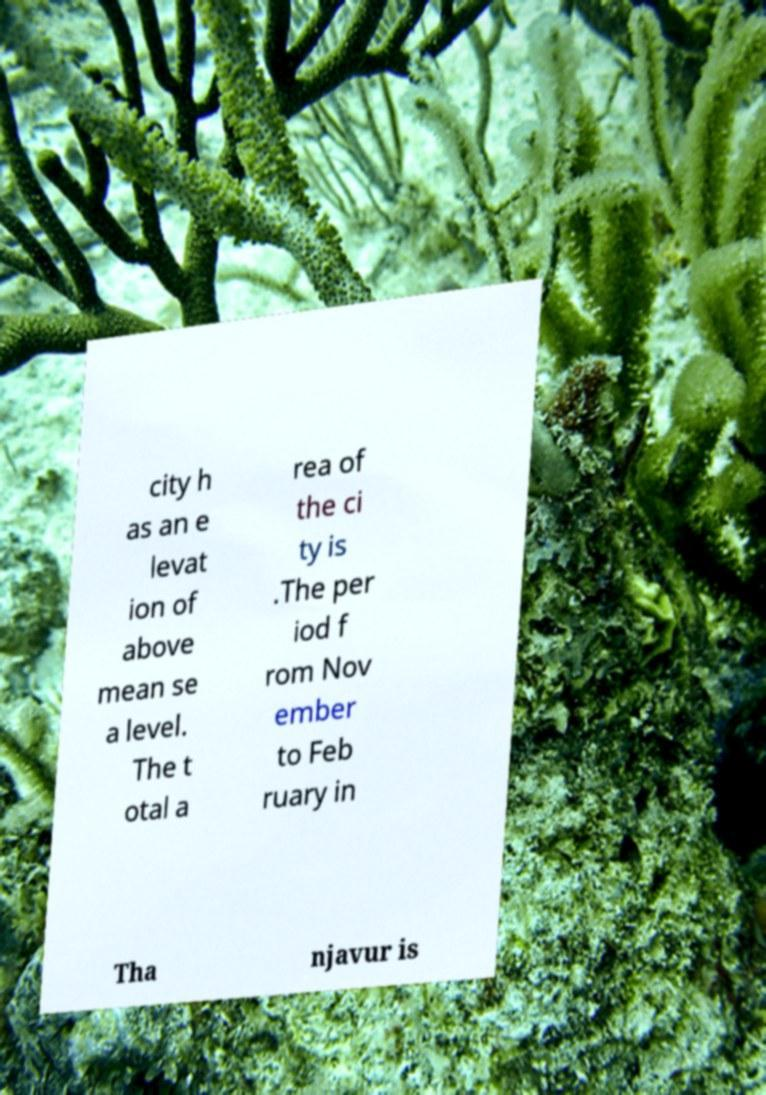What messages or text are displayed in this image? I need them in a readable, typed format. city h as an e levat ion of above mean se a level. The t otal a rea of the ci ty is .The per iod f rom Nov ember to Feb ruary in Tha njavur is 